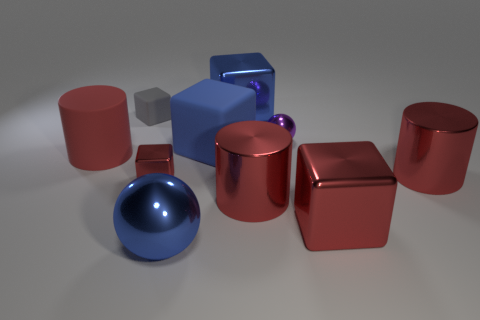Subtract all tiny gray rubber blocks. How many blocks are left? 4 Subtract all red blocks. How many blocks are left? 3 Subtract all cylinders. How many objects are left? 7 Subtract all large cylinders. Subtract all large purple things. How many objects are left? 7 Add 3 blue metal cubes. How many blue metal cubes are left? 4 Add 5 tiny shiny cubes. How many tiny shiny cubes exist? 6 Subtract 0 green spheres. How many objects are left? 10 Subtract 2 cubes. How many cubes are left? 3 Subtract all yellow blocks. Subtract all green cylinders. How many blocks are left? 5 Subtract all green balls. How many gray blocks are left? 1 